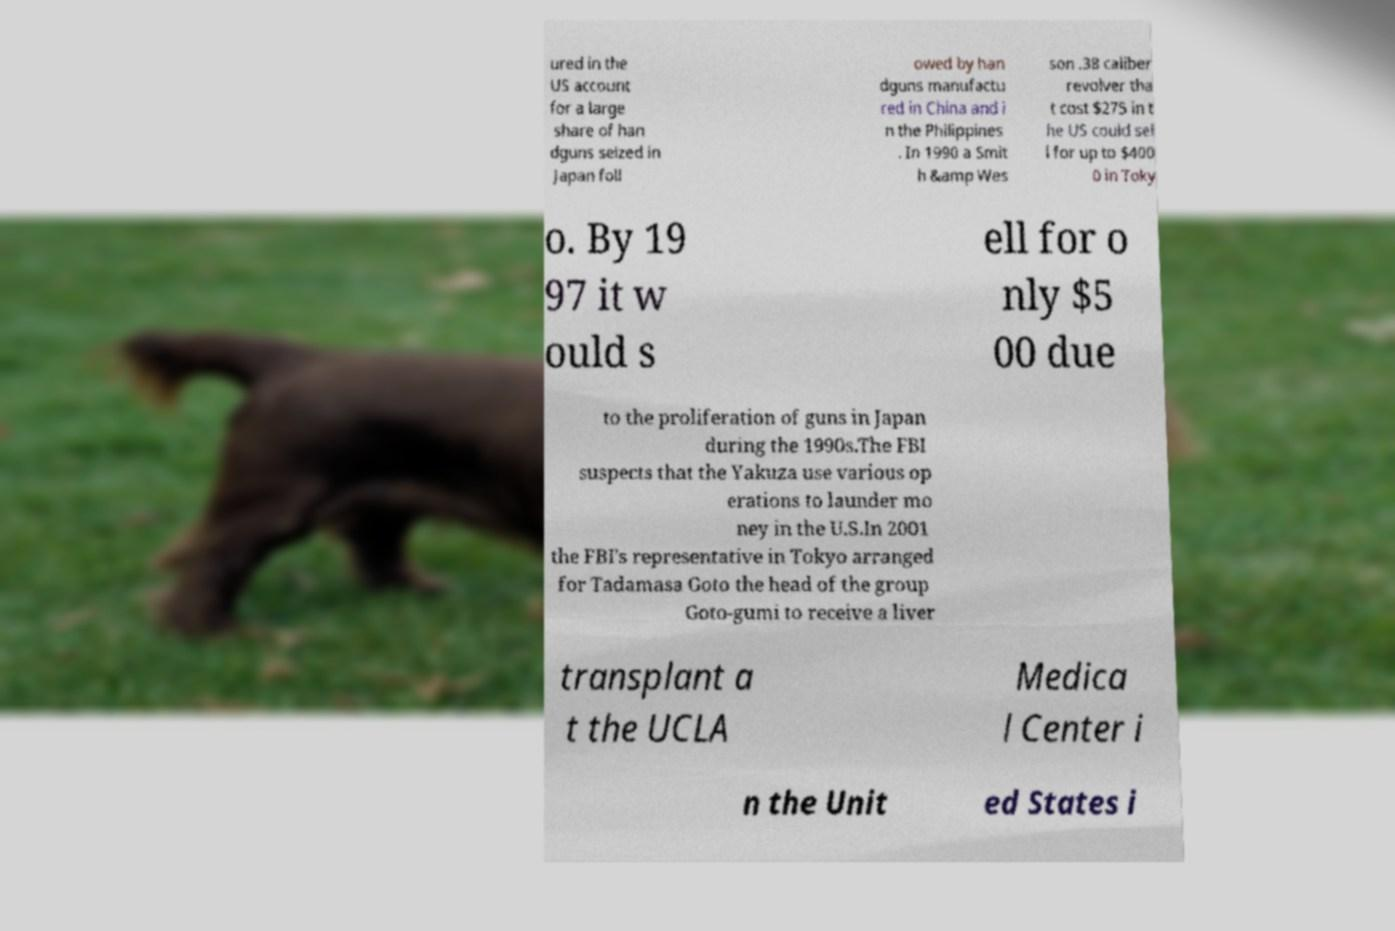There's text embedded in this image that I need extracted. Can you transcribe it verbatim? ured in the US account for a large share of han dguns seized in Japan foll owed by han dguns manufactu red in China and i n the Philippines . In 1990 a Smit h &amp Wes son .38 caliber revolver tha t cost $275 in t he US could sel l for up to $400 0 in Toky o. By 19 97 it w ould s ell for o nly $5 00 due to the proliferation of guns in Japan during the 1990s.The FBI suspects that the Yakuza use various op erations to launder mo ney in the U.S.In 2001 the FBI's representative in Tokyo arranged for Tadamasa Goto the head of the group Goto-gumi to receive a liver transplant a t the UCLA Medica l Center i n the Unit ed States i 